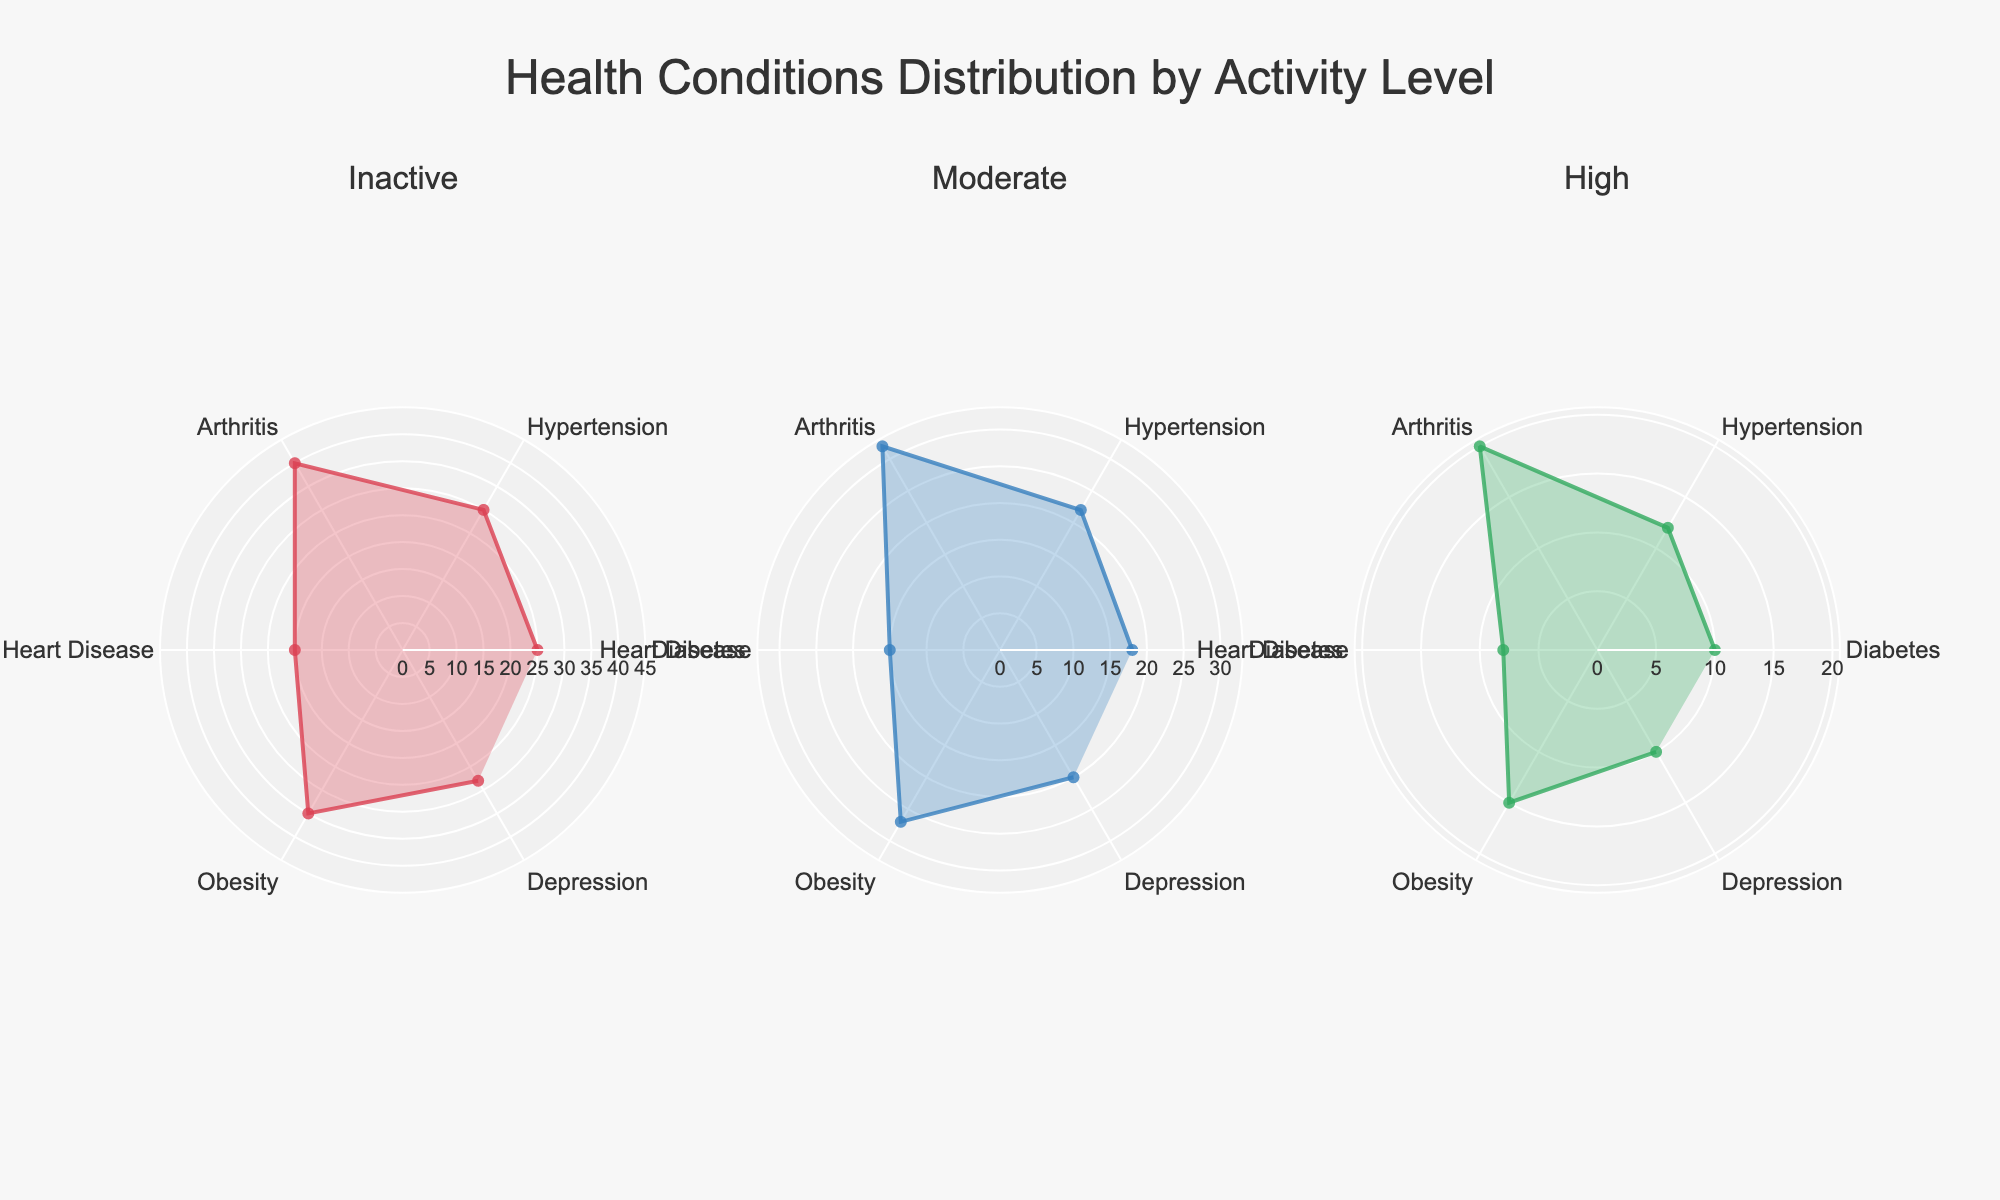What is the title of the radar chart? The title of the radar chart is prominently displayed at the top of the figure in a larger font size compared to other text elements. It reads "Health Conditions Distribution by Activity Level."
Answer: Health Conditions Distribution by Activity Level What are the health conditions listed in the radar chart? The radar chart has axes labeled with various health conditions. These include Diabetes, Hypertension, Arthritis, Heart Disease, Obesity, and Depression.
Answer: Diabetes, Hypertension, Arthritis, Heart Disease, Obesity, Depression Which health condition has the highest value for inactive individuals? To find the highest value for inactive individuals, look at the radar chart for the "Inactive" subplot and identify the health condition that extends farthest from the center. The value for Arthritis is the highest.
Answer: Arthritis What is the average value of Hypertension across all activity levels? First, find the values of Hypertension for Inactive, Moderate, and High activity levels (30, 22, 12). Sum these values (30 + 22 + 12 = 64) and divide by 3 to find the average (64 / 3 ~ 21.33).
Answer: 21.33 How does the value of Obesity compare between inactive and high activity levels? Look at the radar chart values for Obesity in both Inactive and High subplots. The value for Inactive is 35, and the value for High is 15. The value for Inactive is significantly higher.
Answer: Inactive is higher Which activity level has the lowest value for Heart Disease? Observe the radar chart values for Heart Disease across all three subplots. The values are 20 (Inactive), 15 (Moderate), and 8 (High). The lowest value is in the High activity level subplot.
Answer: High How much does the Depression value decrease from inactive to moderate activity levels? Locate the values for Depression in the Inactive and Moderate subplots. The values are 28 (Inactive) and 20 (Moderate). Subtract the Moderate value from the Inactive value (28 - 20 = 8).
Answer: 8 Which health condition has the smallest disparity in values across the three activity levels? Compare the differences in values of each health condition across Inactive, Moderate, and High subplots. Heart Disease has values 20, 15, and 8, showing the smallest overall changes among all conditions evaluated.
Answer: Heart Disease What is the total value of Diabetes for all activity levels combined? Sum the values of Diabetes across Inactive, Moderate, and High activity levels. These values are given as 25, 18, and 10 respectively. (25 + 18 + 10 = 53).
Answer: 53 